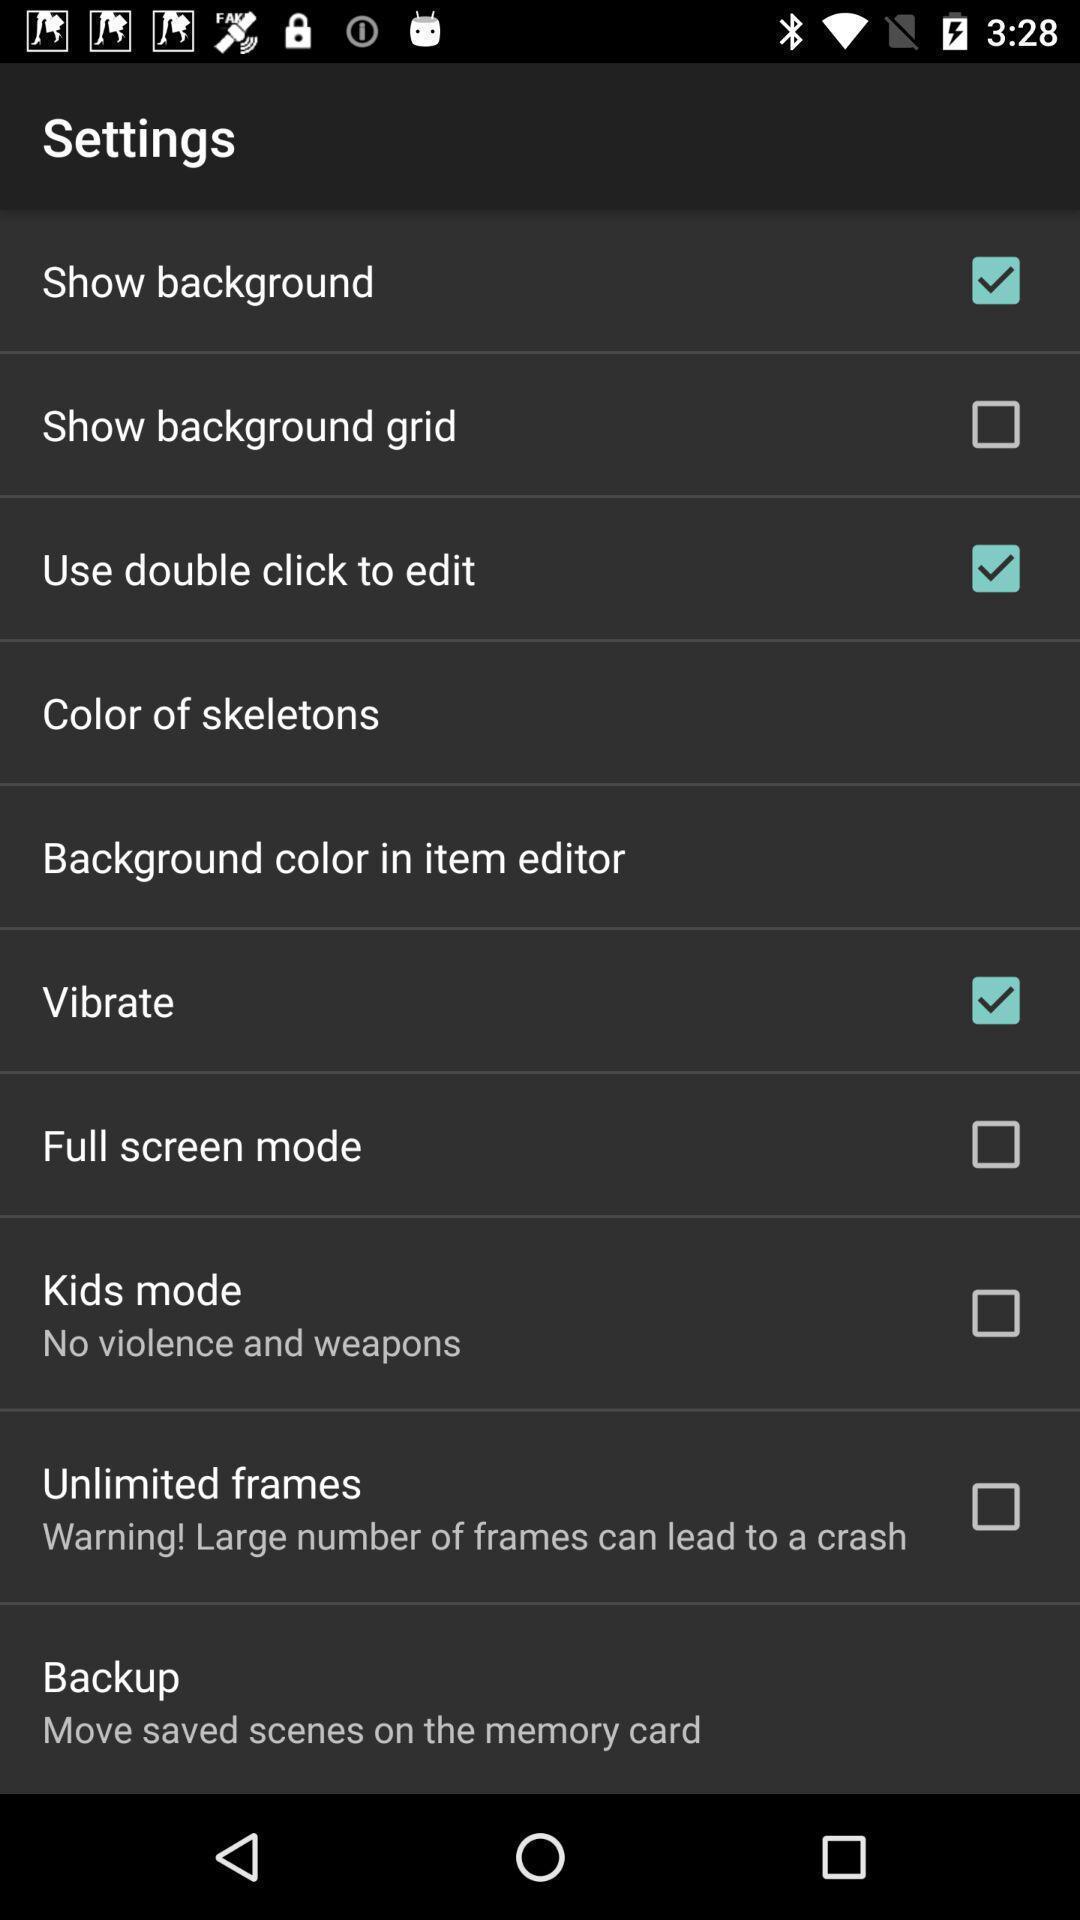Summarize the information in this screenshot. Settings page. 